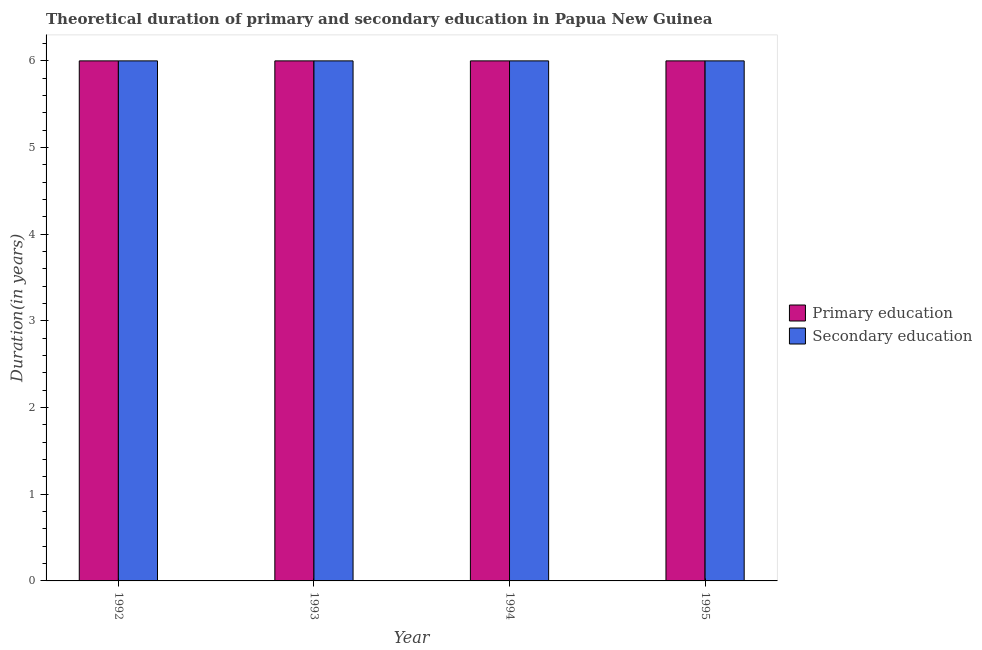How many different coloured bars are there?
Keep it short and to the point. 2. In how many cases, is the number of bars for a given year not equal to the number of legend labels?
Offer a very short reply. 0. What is the duration of primary education in 1992?
Offer a terse response. 6. Across all years, what is the maximum duration of secondary education?
Keep it short and to the point. 6. In which year was the duration of secondary education maximum?
Give a very brief answer. 1992. What is the total duration of secondary education in the graph?
Offer a very short reply. 24. What is the difference between the duration of primary education in 1992 and that in 1995?
Your answer should be very brief. 0. What is the average duration of primary education per year?
Give a very brief answer. 6. What is the ratio of the duration of primary education in 1992 to that in 1993?
Make the answer very short. 1. Is the difference between the duration of secondary education in 1992 and 1993 greater than the difference between the duration of primary education in 1992 and 1993?
Your answer should be compact. No. In how many years, is the duration of secondary education greater than the average duration of secondary education taken over all years?
Keep it short and to the point. 0. What does the 1st bar from the right in 1992 represents?
Your response must be concise. Secondary education. Are all the bars in the graph horizontal?
Make the answer very short. No. What is the difference between two consecutive major ticks on the Y-axis?
Offer a terse response. 1. Are the values on the major ticks of Y-axis written in scientific E-notation?
Offer a very short reply. No. Does the graph contain any zero values?
Your answer should be compact. No. How many legend labels are there?
Provide a short and direct response. 2. How are the legend labels stacked?
Offer a very short reply. Vertical. What is the title of the graph?
Offer a very short reply. Theoretical duration of primary and secondary education in Papua New Guinea. Does "Current education expenditure" appear as one of the legend labels in the graph?
Provide a succinct answer. No. What is the label or title of the Y-axis?
Provide a short and direct response. Duration(in years). What is the Duration(in years) of Primary education in 1994?
Offer a terse response. 6. What is the Duration(in years) in Secondary education in 1994?
Offer a very short reply. 6. What is the Duration(in years) of Primary education in 1995?
Provide a succinct answer. 6. What is the total Duration(in years) in Primary education in the graph?
Give a very brief answer. 24. What is the difference between the Duration(in years) of Primary education in 1992 and that in 1994?
Your answer should be very brief. 0. What is the difference between the Duration(in years) of Secondary education in 1992 and that in 1994?
Offer a very short reply. 0. What is the difference between the Duration(in years) of Primary education in 1992 and that in 1995?
Give a very brief answer. 0. What is the difference between the Duration(in years) of Primary education in 1993 and that in 1994?
Ensure brevity in your answer.  0. What is the difference between the Duration(in years) in Secondary education in 1993 and that in 1994?
Provide a short and direct response. 0. What is the difference between the Duration(in years) of Secondary education in 1994 and that in 1995?
Make the answer very short. 0. What is the difference between the Duration(in years) of Primary education in 1992 and the Duration(in years) of Secondary education in 1994?
Keep it short and to the point. 0. What is the difference between the Duration(in years) in Primary education in 1993 and the Duration(in years) in Secondary education in 1995?
Your answer should be very brief. 0. What is the average Duration(in years) in Primary education per year?
Keep it short and to the point. 6. In the year 1992, what is the difference between the Duration(in years) in Primary education and Duration(in years) in Secondary education?
Make the answer very short. 0. In the year 1993, what is the difference between the Duration(in years) of Primary education and Duration(in years) of Secondary education?
Offer a very short reply. 0. In the year 1994, what is the difference between the Duration(in years) in Primary education and Duration(in years) in Secondary education?
Offer a very short reply. 0. What is the ratio of the Duration(in years) of Primary education in 1992 to that in 1993?
Your answer should be very brief. 1. What is the ratio of the Duration(in years) of Secondary education in 1992 to that in 1993?
Your response must be concise. 1. What is the ratio of the Duration(in years) of Secondary education in 1992 to that in 1994?
Offer a terse response. 1. What is the ratio of the Duration(in years) in Primary education in 1992 to that in 1995?
Offer a very short reply. 1. What is the ratio of the Duration(in years) of Secondary education in 1992 to that in 1995?
Offer a terse response. 1. What is the ratio of the Duration(in years) of Primary education in 1993 to that in 1994?
Your answer should be very brief. 1. What is the ratio of the Duration(in years) of Secondary education in 1993 to that in 1995?
Offer a terse response. 1. What is the ratio of the Duration(in years) in Secondary education in 1994 to that in 1995?
Offer a terse response. 1. What is the difference between the highest and the second highest Duration(in years) in Primary education?
Keep it short and to the point. 0. What is the difference between the highest and the second highest Duration(in years) in Secondary education?
Ensure brevity in your answer.  0. 